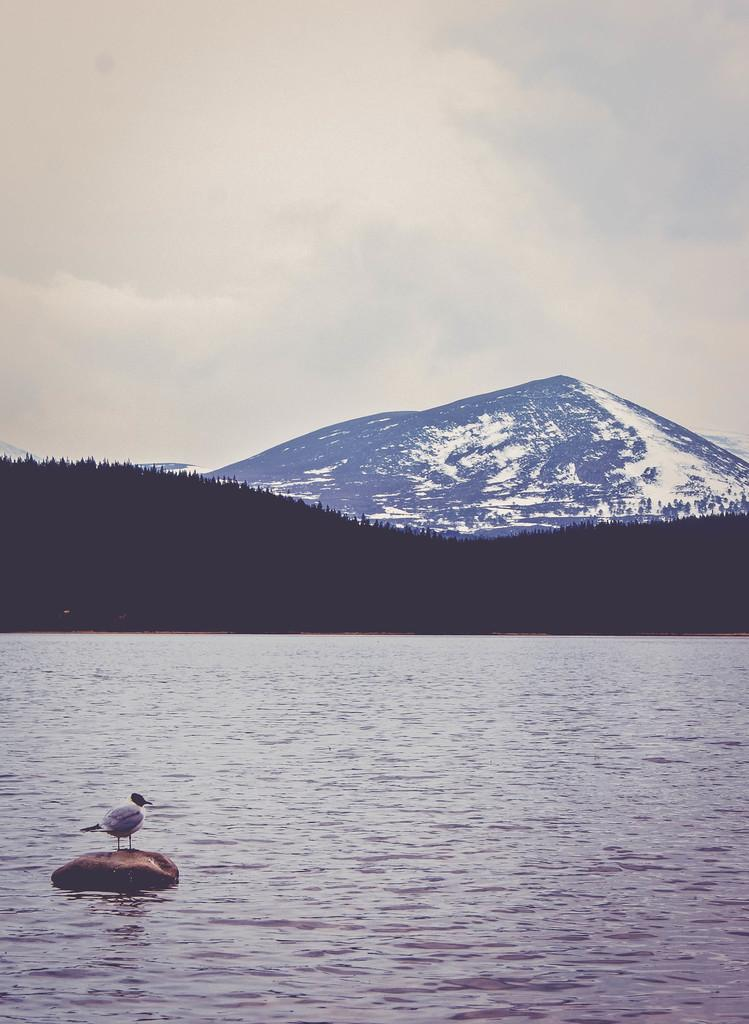What geographical feature is the main subject of the image? There is a mountain in the image. What is the condition of the mountain in the image? The mountain is covered with snow. What can be seen in the middle of the image? There are trees in the middle of the image. What is visible at the bottom of the image? There is water and a rock at the bottom of the image. Is there any wildlife present in the image? Yes, there is a bird on the rock. What type of machine can be seen operating at the top of the mountain in the image? There is no machine present in the image; it features a snow-covered mountain with trees, water, a rock, and a bird. Is there any evidence of a fight taking place on the rock in the image? There is no fight or any indication of conflict present in the image. 